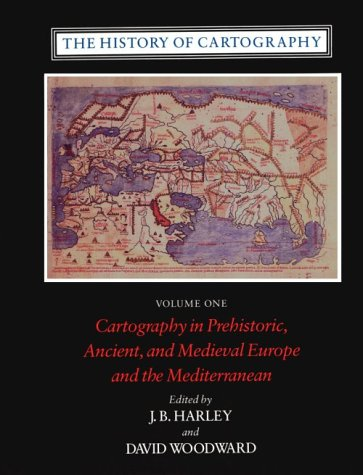What type of book is this? This book falls under the category of 'Science & Math', specifically focusing on the scientific aspects and mathematical techniques used in cartography through various historical periods. 